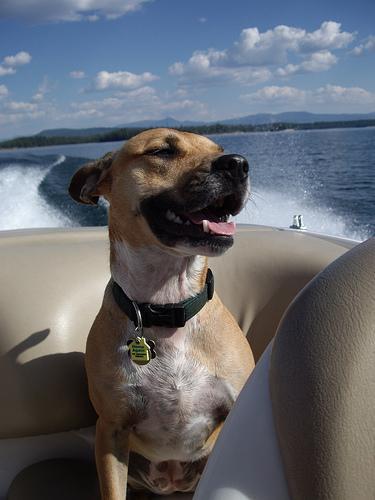How many dogs are there?
Give a very brief answer. 1. 